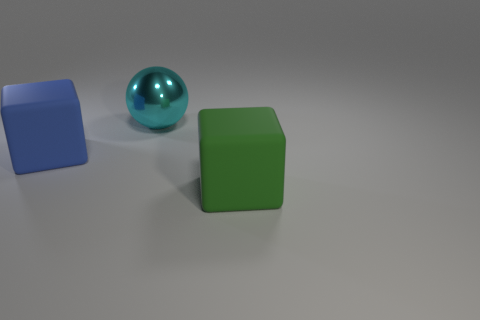Is there anything else of the same color as the sphere?
Provide a short and direct response. No. What is the size of the other thing that is the same material as the blue object?
Your response must be concise. Large. What material is the big block that is behind the rubber object that is right of the matte thing behind the big green matte thing?
Offer a terse response. Rubber. Is the number of balls less than the number of tiny purple metal objects?
Offer a very short reply. No. Are the large cyan sphere and the big green block made of the same material?
Give a very brief answer. No. There is a big block behind the big green block; is its color the same as the large shiny ball?
Keep it short and to the point. No. There is a large block that is behind the green cube; what number of objects are behind it?
Keep it short and to the point. 1. There is a rubber thing that is the same size as the blue cube; what color is it?
Provide a succinct answer. Green. There is a block to the left of the green cube; what is its material?
Your answer should be very brief. Rubber. What is the material of the large object that is both right of the large blue rubber object and in front of the ball?
Your answer should be very brief. Rubber. 